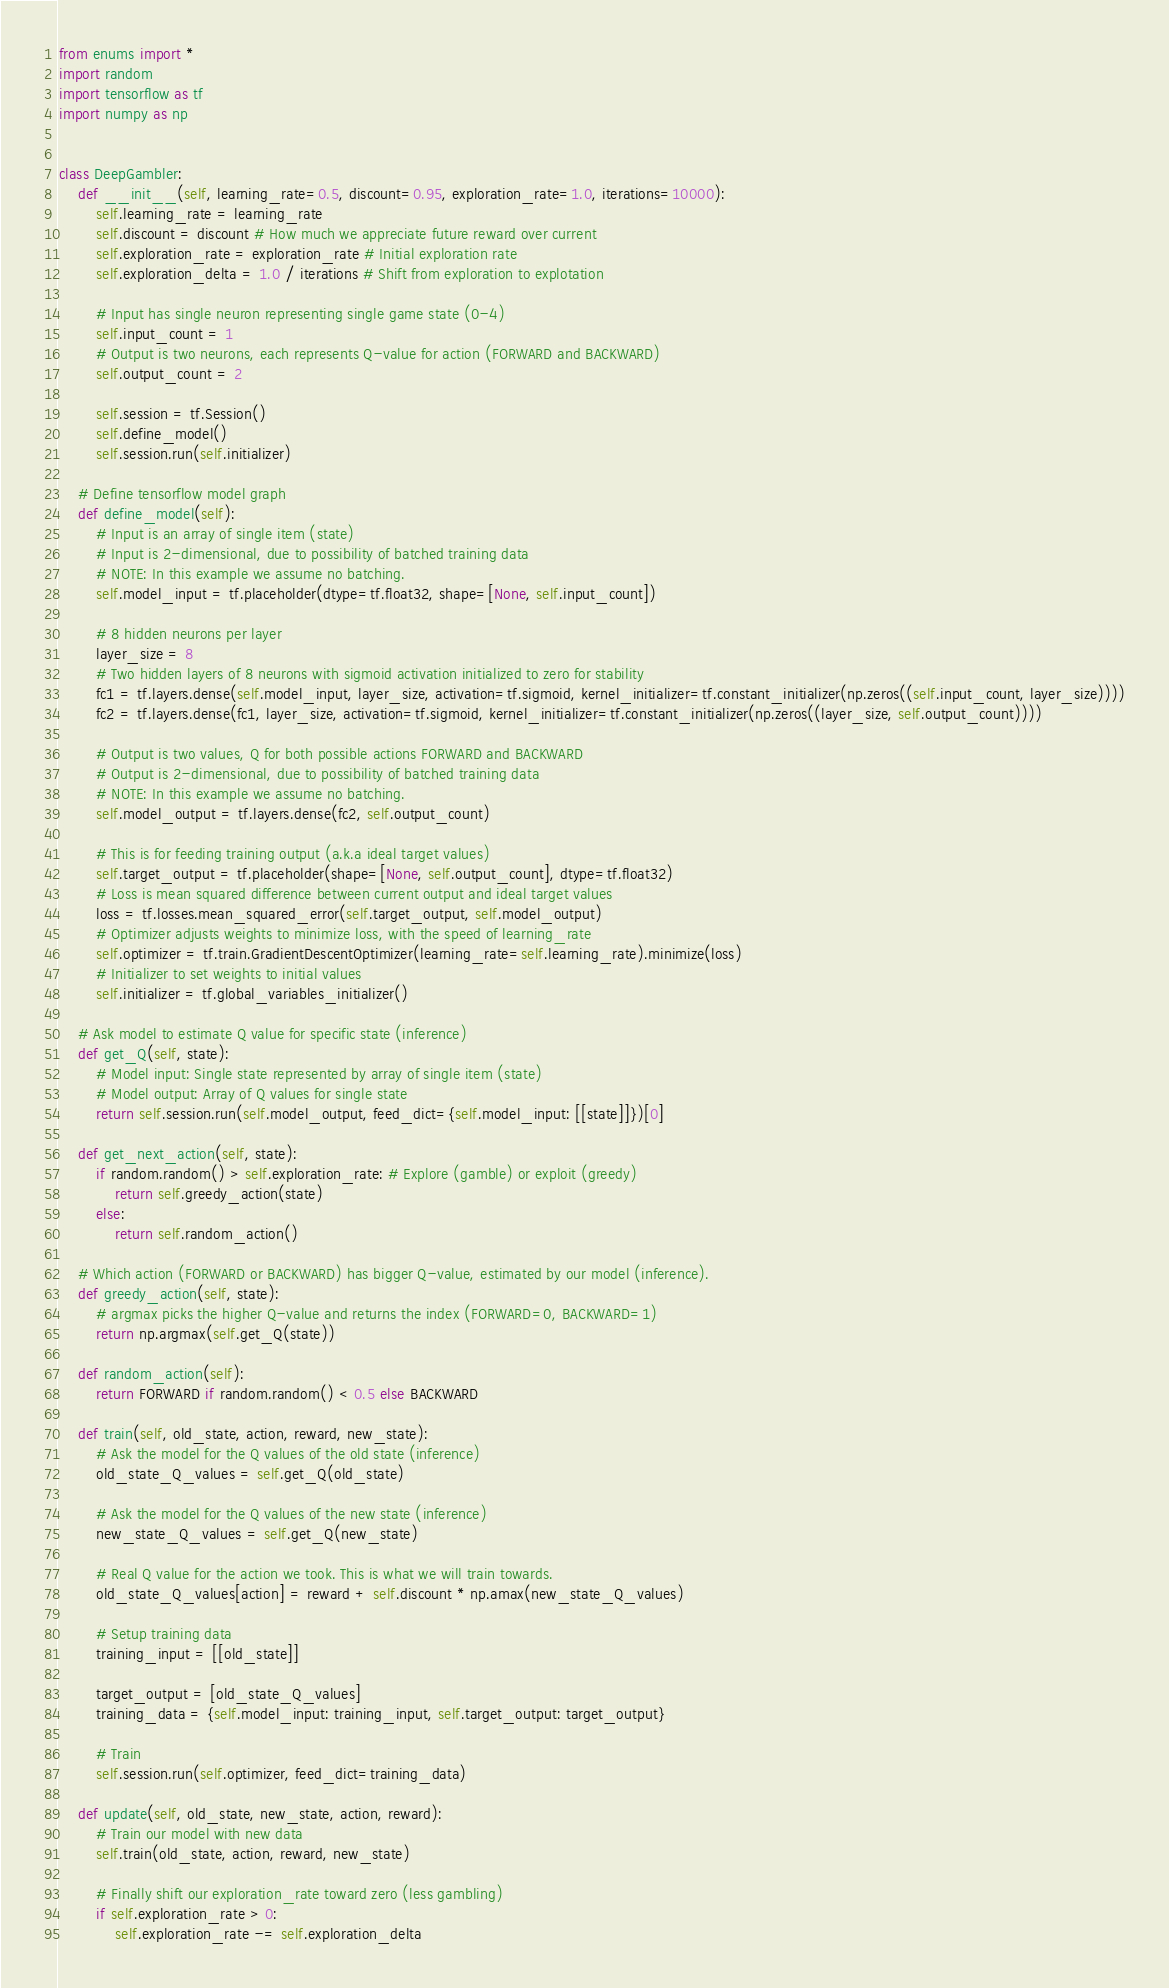Convert code to text. <code><loc_0><loc_0><loc_500><loc_500><_Python_>from enums import *
import random
import tensorflow as tf
import numpy as np


class DeepGambler:
    def __init__(self, learning_rate=0.5, discount=0.95, exploration_rate=1.0, iterations=10000):
        self.learning_rate = learning_rate
        self.discount = discount # How much we appreciate future reward over current
        self.exploration_rate = exploration_rate # Initial exploration rate
        self.exploration_delta = 1.0 / iterations # Shift from exploration to explotation

        # Input has single neuron representing single game state (0-4)
        self.input_count = 1
        # Output is two neurons, each represents Q-value for action (FORWARD and BACKWARD)
        self.output_count = 2

        self.session = tf.Session()
        self.define_model()
        self.session.run(self.initializer)

    # Define tensorflow model graph
    def define_model(self):
        # Input is an array of single item (state)
        # Input is 2-dimensional, due to possibility of batched training data
        # NOTE: In this example we assume no batching.
        self.model_input = tf.placeholder(dtype=tf.float32, shape=[None, self.input_count])

        # 8 hidden neurons per layer
        layer_size = 8
        # Two hidden layers of 8 neurons with sigmoid activation initialized to zero for stability
        fc1 = tf.layers.dense(self.model_input, layer_size, activation=tf.sigmoid, kernel_initializer=tf.constant_initializer(np.zeros((self.input_count, layer_size))))
        fc2 = tf.layers.dense(fc1, layer_size, activation=tf.sigmoid, kernel_initializer=tf.constant_initializer(np.zeros((layer_size, self.output_count))))

        # Output is two values, Q for both possible actions FORWARD and BACKWARD
        # Output is 2-dimensional, due to possibility of batched training data
        # NOTE: In this example we assume no batching.
        self.model_output = tf.layers.dense(fc2, self.output_count)

        # This is for feeding training output (a.k.a ideal target values)
        self.target_output = tf.placeholder(shape=[None, self.output_count], dtype=tf.float32)
        # Loss is mean squared difference between current output and ideal target values
        loss = tf.losses.mean_squared_error(self.target_output, self.model_output)
        # Optimizer adjusts weights to minimize loss, with the speed of learning_rate
        self.optimizer = tf.train.GradientDescentOptimizer(learning_rate=self.learning_rate).minimize(loss)
        # Initializer to set weights to initial values
        self.initializer = tf.global_variables_initializer()

    # Ask model to estimate Q value for specific state (inference)
    def get_Q(self, state):
        # Model input: Single state represented by array of single item (state)
        # Model output: Array of Q values for single state
        return self.session.run(self.model_output, feed_dict={self.model_input: [[state]]})[0]

    def get_next_action(self, state):
        if random.random() > self.exploration_rate: # Explore (gamble) or exploit (greedy)
            return self.greedy_action(state)
        else:
            return self.random_action()

    # Which action (FORWARD or BACKWARD) has bigger Q-value, estimated by our model (inference).
    def greedy_action(self, state):
        # argmax picks the higher Q-value and returns the index (FORWARD=0, BACKWARD=1)
        return np.argmax(self.get_Q(state))

    def random_action(self):
        return FORWARD if random.random() < 0.5 else BACKWARD

    def train(self, old_state, action, reward, new_state):
        # Ask the model for the Q values of the old state (inference)
        old_state_Q_values = self.get_Q(old_state)

        # Ask the model for the Q values of the new state (inference)
        new_state_Q_values = self.get_Q(new_state)

        # Real Q value for the action we took. This is what we will train towards.
        old_state_Q_values[action] = reward + self.discount * np.amax(new_state_Q_values)
        
        # Setup training data
        training_input = [[old_state]]

        target_output = [old_state_Q_values]
        training_data = {self.model_input: training_input, self.target_output: target_output}

        # Train
        self.session.run(self.optimizer, feed_dict=training_data)

    def update(self, old_state, new_state, action, reward):
        # Train our model with new data
        self.train(old_state, action, reward, new_state)

        # Finally shift our exploration_rate toward zero (less gambling)
        if self.exploration_rate > 0:
            self.exploration_rate -= self.exploration_delta
</code> 